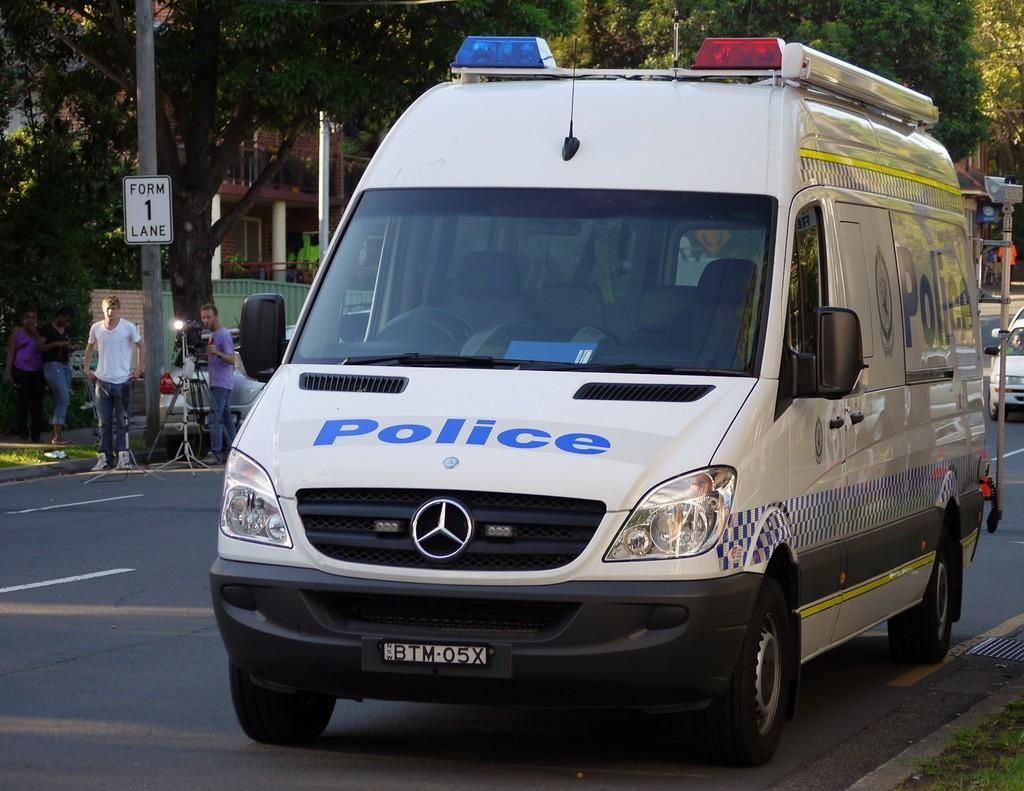Provide a one-sentence caption for the provided image. A Mercedes van says police with a plate that says BTM05X. 